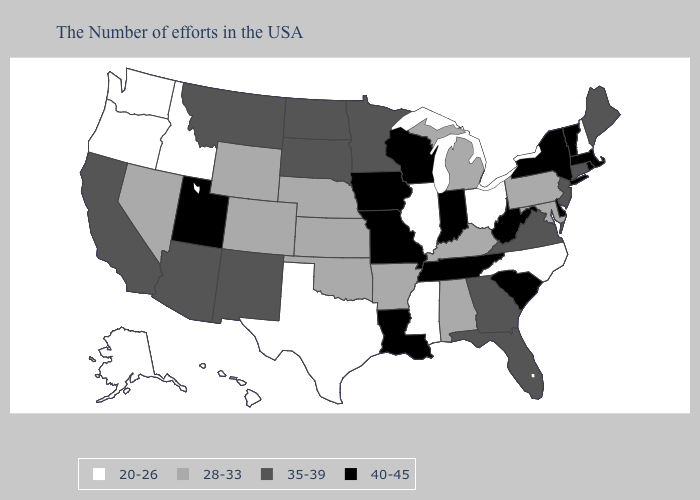How many symbols are there in the legend?
Quick response, please. 4. Does Minnesota have the same value as Delaware?
Be succinct. No. Among the states that border Louisiana , does Arkansas have the highest value?
Answer briefly. Yes. Name the states that have a value in the range 40-45?
Be succinct. Massachusetts, Rhode Island, Vermont, New York, Delaware, South Carolina, West Virginia, Indiana, Tennessee, Wisconsin, Louisiana, Missouri, Iowa, Utah. Name the states that have a value in the range 35-39?
Give a very brief answer. Maine, Connecticut, New Jersey, Virginia, Florida, Georgia, Minnesota, South Dakota, North Dakota, New Mexico, Montana, Arizona, California. Does Delaware have the highest value in the South?
Concise answer only. Yes. Among the states that border Oregon , does Nevada have the highest value?
Write a very short answer. No. Does New Hampshire have a lower value than Washington?
Concise answer only. No. What is the value of Tennessee?
Quick response, please. 40-45. Does the first symbol in the legend represent the smallest category?
Be succinct. Yes. Among the states that border Nevada , which have the lowest value?
Concise answer only. Idaho, Oregon. Does New Jersey have the highest value in the USA?
Concise answer only. No. What is the highest value in the West ?
Be succinct. 40-45. What is the lowest value in the USA?
Give a very brief answer. 20-26. What is the value of Louisiana?
Give a very brief answer. 40-45. 